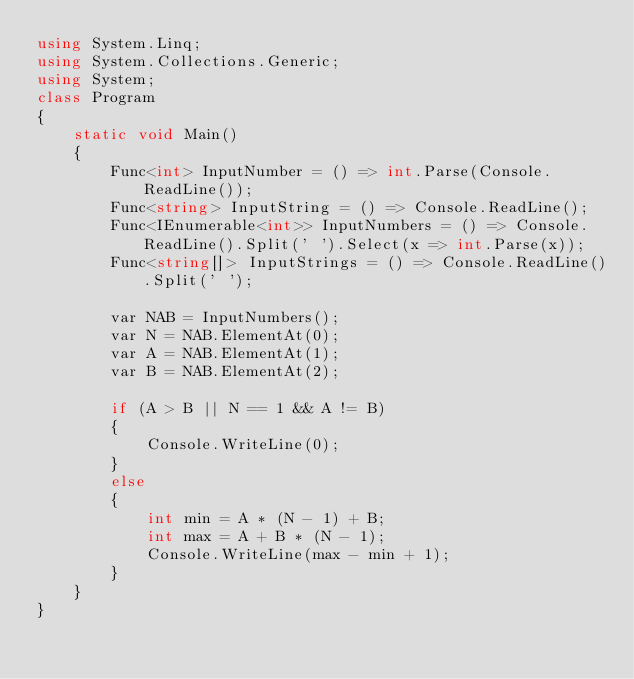Convert code to text. <code><loc_0><loc_0><loc_500><loc_500><_C#_>using System.Linq;
using System.Collections.Generic;
using System;
class Program
{
    static void Main()
    {
        Func<int> InputNumber = () => int.Parse(Console.ReadLine());
        Func<string> InputString = () => Console.ReadLine();
        Func<IEnumerable<int>> InputNumbers = () => Console.ReadLine().Split(' ').Select(x => int.Parse(x));
        Func<string[]> InputStrings = () => Console.ReadLine().Split(' ');
        
        var NAB = InputNumbers();
        var N = NAB.ElementAt(0);
        var A = NAB.ElementAt(1);
        var B = NAB.ElementAt(2);

        if (A > B || N == 1 && A != B)
        {
            Console.WriteLine(0);
        }
        else
        {
            int min = A * (N - 1) + B;
            int max = A + B * (N - 1);
            Console.WriteLine(max - min + 1);
        }
    }
}</code> 